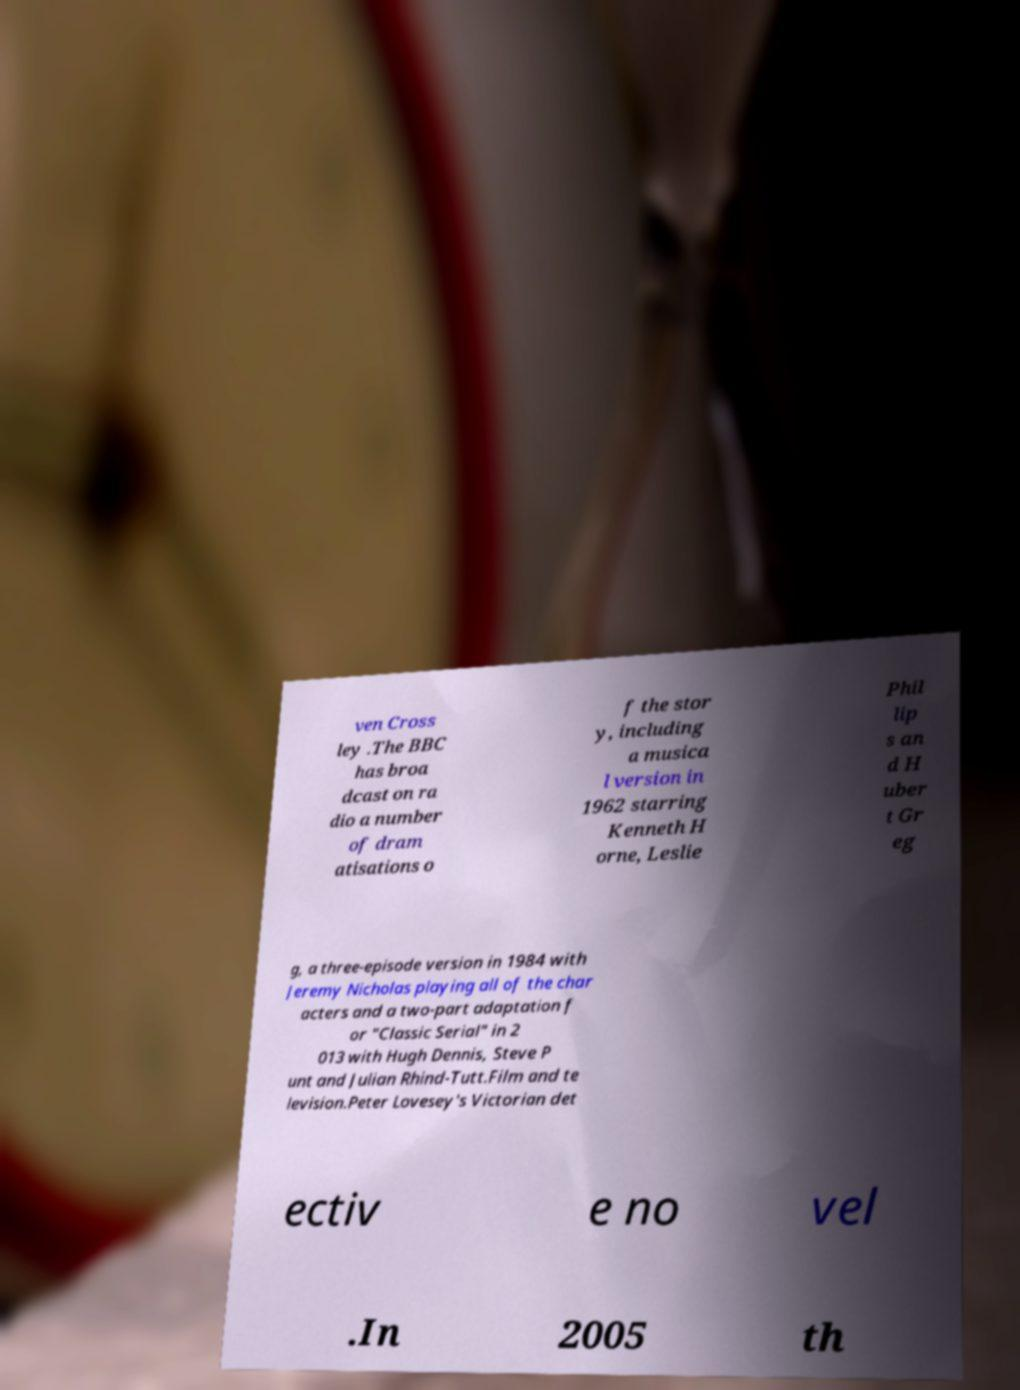Please identify and transcribe the text found in this image. ven Cross ley .The BBC has broa dcast on ra dio a number of dram atisations o f the stor y, including a musica l version in 1962 starring Kenneth H orne, Leslie Phil lip s an d H uber t Gr eg g, a three-episode version in 1984 with Jeremy Nicholas playing all of the char acters and a two-part adaptation f or "Classic Serial" in 2 013 with Hugh Dennis, Steve P unt and Julian Rhind-Tutt.Film and te levision.Peter Lovesey's Victorian det ectiv e no vel .In 2005 th 